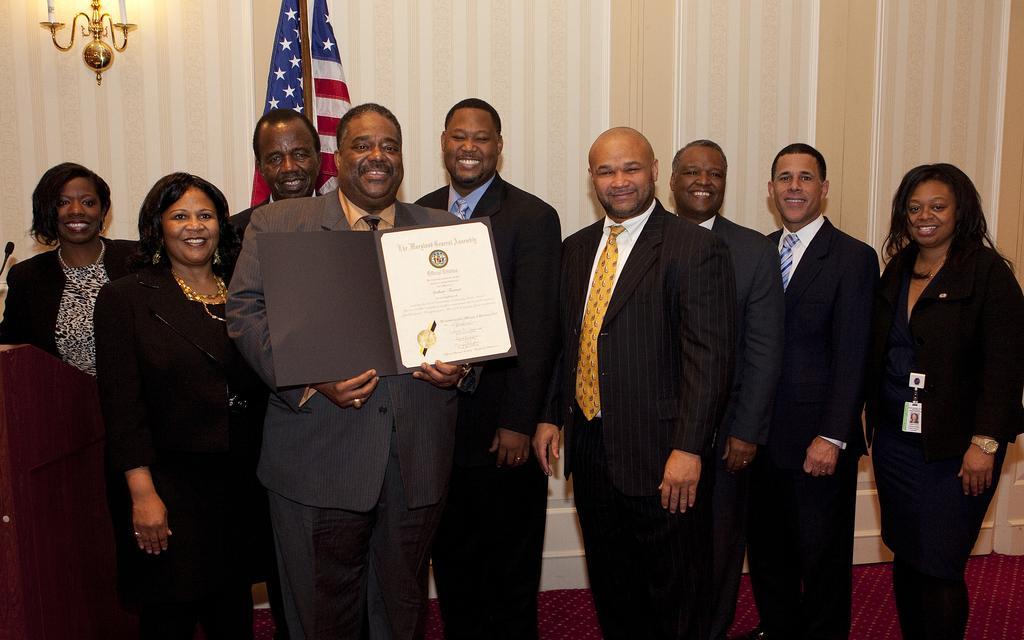Can you describe this image briefly? In this picture we can see a group of people wore blazers and standing on the floor and smiling and a man holding a certificate with his hands, podium, mic, flag, ties, id card, candle stand and in the background we can see the wall. 